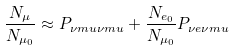Convert formula to latex. <formula><loc_0><loc_0><loc_500><loc_500>\frac { N _ { \mu } } { N _ { \mu _ { 0 } } } \approx P _ { \nu m u \nu m u } + \frac { N _ { e _ { 0 } } } { N _ { \mu _ { 0 } } } P _ { \nu e \nu m u }</formula> 